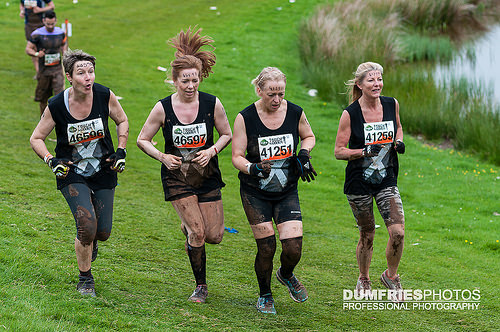<image>
Can you confirm if the runner is next to the runner? No. The runner is not positioned next to the runner. They are located in different areas of the scene. 